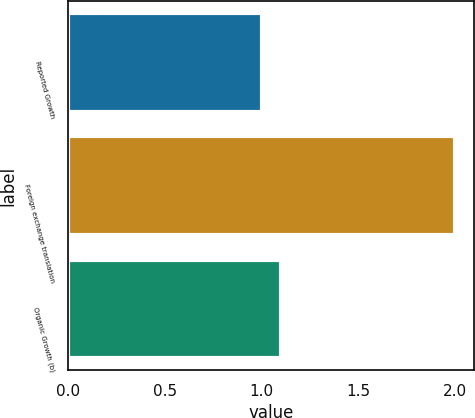Convert chart to OTSL. <chart><loc_0><loc_0><loc_500><loc_500><bar_chart><fcel>Reported Growth<fcel>Foreign exchange translation<fcel>Organic Growth (b)<nl><fcel>1<fcel>2<fcel>1.1<nl></chart> 